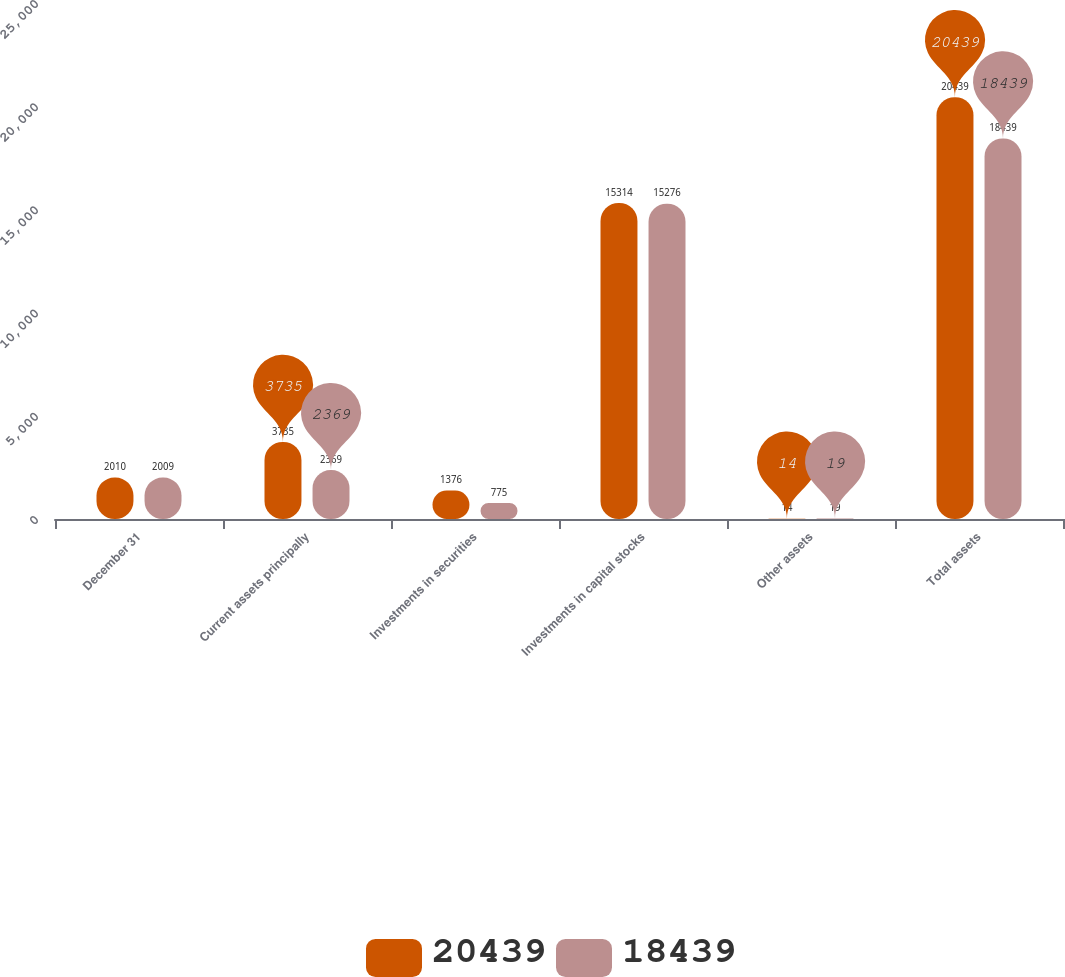Convert chart. <chart><loc_0><loc_0><loc_500><loc_500><stacked_bar_chart><ecel><fcel>December 31<fcel>Current assets principally<fcel>Investments in securities<fcel>Investments in capital stocks<fcel>Other assets<fcel>Total assets<nl><fcel>20439<fcel>2010<fcel>3735<fcel>1376<fcel>15314<fcel>14<fcel>20439<nl><fcel>18439<fcel>2009<fcel>2369<fcel>775<fcel>15276<fcel>19<fcel>18439<nl></chart> 